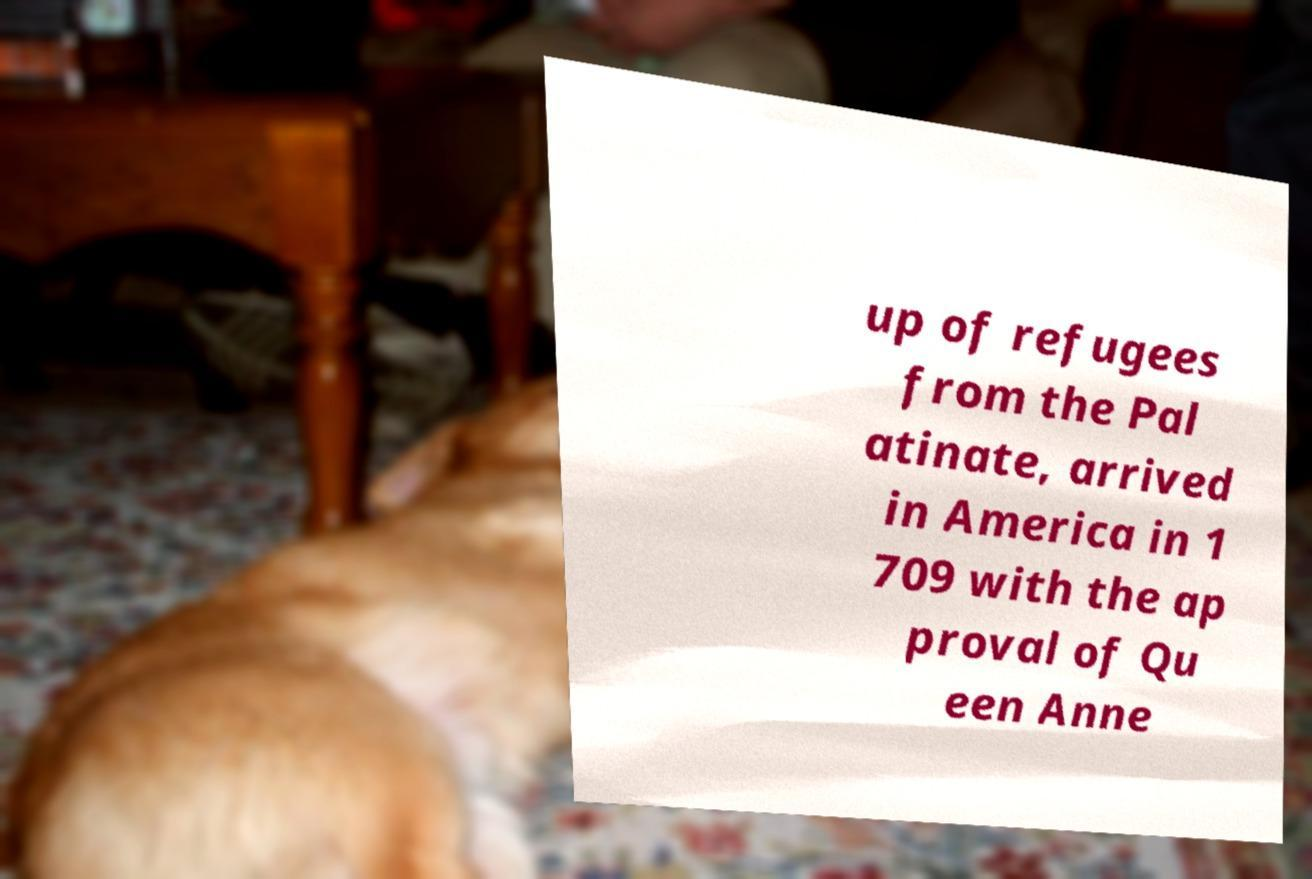What messages or text are displayed in this image? I need them in a readable, typed format. up of refugees from the Pal atinate, arrived in America in 1 709 with the ap proval of Qu een Anne 